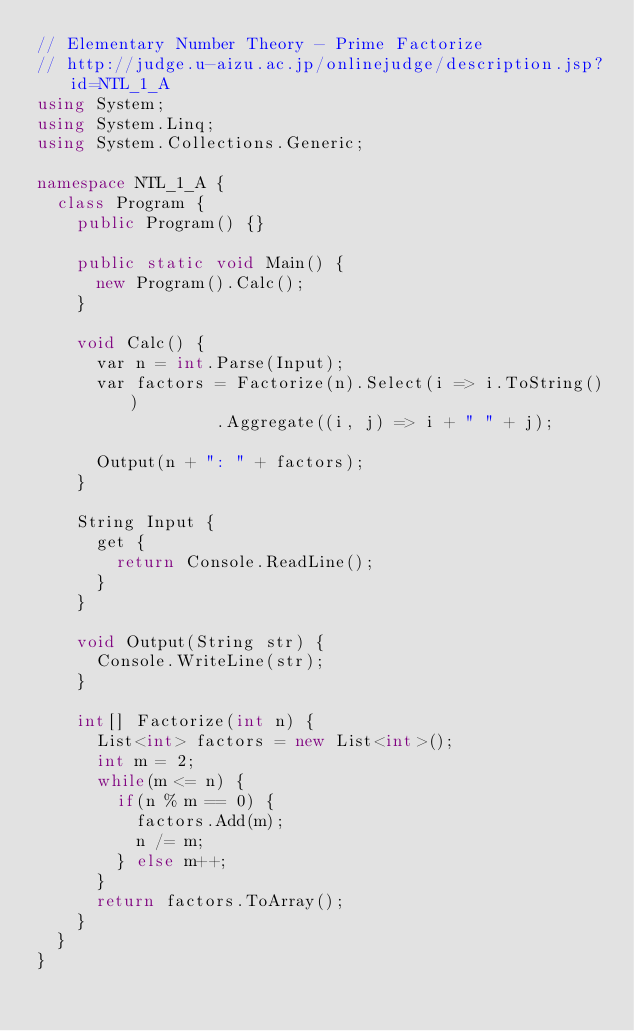<code> <loc_0><loc_0><loc_500><loc_500><_C#_>// Elementary Number Theory - Prime Factorize
// http://judge.u-aizu.ac.jp/onlinejudge/description.jsp?id=NTL_1_A
using System;
using System.Linq;
using System.Collections.Generic;

namespace NTL_1_A {
	class Program {
		public Program() {}
		
		public static void Main() {
			new Program().Calc();
		}
		
		void Calc() {
			var n = int.Parse(Input);
			var factors = Factorize(n).Select(i => i.ToString())
									.Aggregate((i, j) => i + " " + j);
			
			Output(n + ": " + factors);
		}
		
		String Input {
			get {
				return Console.ReadLine();
			}
		}
		
		void Output(String str) {
			Console.WriteLine(str);
		}
		
		int[] Factorize(int n) {
			List<int> factors = new List<int>();
			int m = 2;
			while(m <= n) {
				if(n % m == 0) {
					factors.Add(m);
					n /= m;
				} else m++;
			}
			return factors.ToArray();
		}
	}
}</code> 